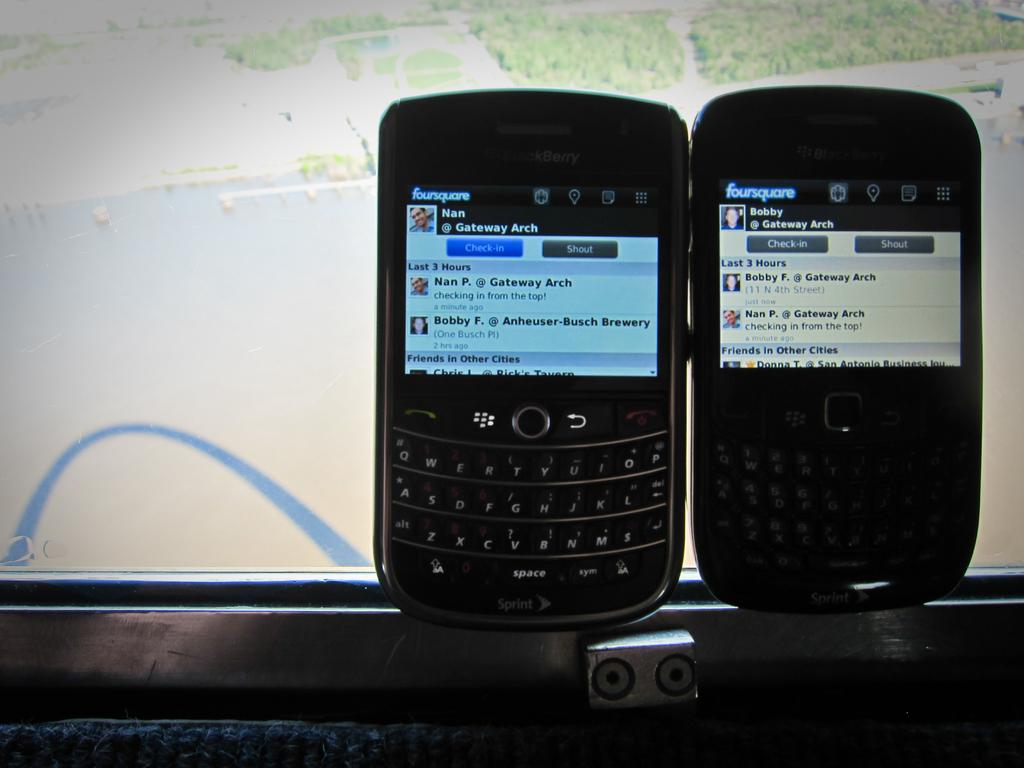Provide a one-sentence caption for the provided image. Both of the cell phones are displaying screens from Foursquare on them. 